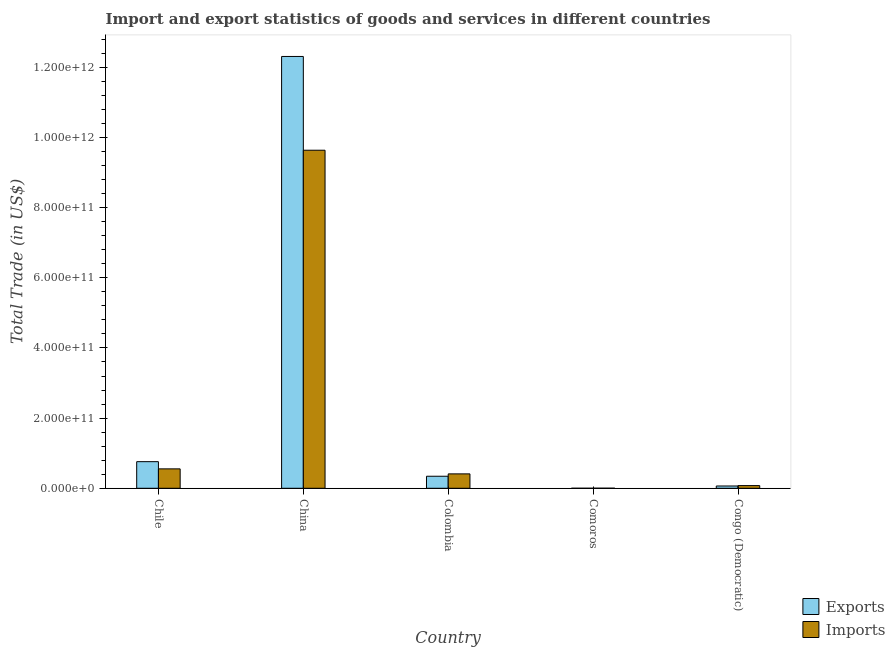Are the number of bars per tick equal to the number of legend labels?
Your response must be concise. Yes. Are the number of bars on each tick of the X-axis equal?
Make the answer very short. Yes. What is the label of the 4th group of bars from the left?
Your answer should be very brief. Comoros. What is the export of goods and services in Comoros?
Provide a short and direct response. 7.15e+07. Across all countries, what is the maximum imports of goods and services?
Provide a succinct answer. 9.63e+11. Across all countries, what is the minimum export of goods and services?
Provide a succinct answer. 7.15e+07. In which country was the imports of goods and services maximum?
Your answer should be very brief. China. In which country was the export of goods and services minimum?
Your response must be concise. Comoros. What is the total export of goods and services in the graph?
Ensure brevity in your answer.  1.35e+12. What is the difference between the export of goods and services in Comoros and that in Congo (Democratic)?
Provide a short and direct response. -6.47e+09. What is the difference between the imports of goods and services in China and the export of goods and services in Chile?
Ensure brevity in your answer.  8.88e+11. What is the average export of goods and services per country?
Provide a succinct answer. 2.69e+11. What is the difference between the export of goods and services and imports of goods and services in Colombia?
Offer a terse response. -6.74e+09. What is the ratio of the imports of goods and services in Comoros to that in Congo (Democratic)?
Your answer should be very brief. 0.03. What is the difference between the highest and the second highest imports of goods and services?
Your answer should be compact. 9.08e+11. What is the difference between the highest and the lowest imports of goods and services?
Your answer should be very brief. 9.63e+11. What does the 2nd bar from the left in Comoros represents?
Ensure brevity in your answer.  Imports. What does the 2nd bar from the right in China represents?
Your answer should be very brief. Exports. What is the difference between two consecutive major ticks on the Y-axis?
Ensure brevity in your answer.  2.00e+11. Are the values on the major ticks of Y-axis written in scientific E-notation?
Make the answer very short. Yes. Does the graph contain any zero values?
Make the answer very short. No. Does the graph contain grids?
Give a very brief answer. No. How many legend labels are there?
Your answer should be compact. 2. How are the legend labels stacked?
Provide a succinct answer. Vertical. What is the title of the graph?
Offer a very short reply. Import and export statistics of goods and services in different countries. Does "Nitrous oxide" appear as one of the legend labels in the graph?
Keep it short and to the point. No. What is the label or title of the Y-axis?
Your response must be concise. Total Trade (in US$). What is the Total Trade (in US$) in Exports in Chile?
Ensure brevity in your answer.  7.59e+1. What is the Total Trade (in US$) in Imports in Chile?
Offer a very short reply. 5.53e+1. What is the Total Trade (in US$) of Exports in China?
Keep it short and to the point. 1.23e+12. What is the Total Trade (in US$) of Imports in China?
Keep it short and to the point. 9.63e+11. What is the Total Trade (in US$) of Exports in Colombia?
Make the answer very short. 3.43e+1. What is the Total Trade (in US$) in Imports in Colombia?
Offer a very short reply. 4.10e+1. What is the Total Trade (in US$) of Exports in Comoros?
Make the answer very short. 7.15e+07. What is the Total Trade (in US$) in Imports in Comoros?
Provide a short and direct response. 1.91e+08. What is the Total Trade (in US$) of Exports in Congo (Democratic)?
Make the answer very short. 6.54e+09. What is the Total Trade (in US$) of Imports in Congo (Democratic)?
Provide a short and direct response. 7.64e+09. Across all countries, what is the maximum Total Trade (in US$) in Exports?
Your answer should be very brief. 1.23e+12. Across all countries, what is the maximum Total Trade (in US$) in Imports?
Offer a very short reply. 9.63e+11. Across all countries, what is the minimum Total Trade (in US$) of Exports?
Make the answer very short. 7.15e+07. Across all countries, what is the minimum Total Trade (in US$) of Imports?
Provide a short and direct response. 1.91e+08. What is the total Total Trade (in US$) of Exports in the graph?
Provide a succinct answer. 1.35e+12. What is the total Total Trade (in US$) of Imports in the graph?
Provide a succinct answer. 1.07e+12. What is the difference between the Total Trade (in US$) in Exports in Chile and that in China?
Your answer should be very brief. -1.15e+12. What is the difference between the Total Trade (in US$) of Imports in Chile and that in China?
Make the answer very short. -9.08e+11. What is the difference between the Total Trade (in US$) in Exports in Chile and that in Colombia?
Ensure brevity in your answer.  4.16e+1. What is the difference between the Total Trade (in US$) in Imports in Chile and that in Colombia?
Offer a very short reply. 1.43e+1. What is the difference between the Total Trade (in US$) in Exports in Chile and that in Comoros?
Your response must be concise. 7.58e+1. What is the difference between the Total Trade (in US$) of Imports in Chile and that in Comoros?
Offer a terse response. 5.51e+1. What is the difference between the Total Trade (in US$) of Exports in Chile and that in Congo (Democratic)?
Provide a succinct answer. 6.93e+1. What is the difference between the Total Trade (in US$) in Imports in Chile and that in Congo (Democratic)?
Your answer should be very brief. 4.77e+1. What is the difference between the Total Trade (in US$) in Exports in China and that in Colombia?
Your answer should be compact. 1.20e+12. What is the difference between the Total Trade (in US$) in Imports in China and that in Colombia?
Give a very brief answer. 9.22e+11. What is the difference between the Total Trade (in US$) in Exports in China and that in Comoros?
Your answer should be very brief. 1.23e+12. What is the difference between the Total Trade (in US$) of Imports in China and that in Comoros?
Your answer should be very brief. 9.63e+11. What is the difference between the Total Trade (in US$) in Exports in China and that in Congo (Democratic)?
Offer a terse response. 1.22e+12. What is the difference between the Total Trade (in US$) of Imports in China and that in Congo (Democratic)?
Provide a short and direct response. 9.56e+11. What is the difference between the Total Trade (in US$) of Exports in Colombia and that in Comoros?
Offer a very short reply. 3.42e+1. What is the difference between the Total Trade (in US$) of Imports in Colombia and that in Comoros?
Offer a very short reply. 4.09e+1. What is the difference between the Total Trade (in US$) of Exports in Colombia and that in Congo (Democratic)?
Give a very brief answer. 2.78e+1. What is the difference between the Total Trade (in US$) of Imports in Colombia and that in Congo (Democratic)?
Give a very brief answer. 3.34e+1. What is the difference between the Total Trade (in US$) of Exports in Comoros and that in Congo (Democratic)?
Give a very brief answer. -6.47e+09. What is the difference between the Total Trade (in US$) in Imports in Comoros and that in Congo (Democratic)?
Provide a succinct answer. -7.45e+09. What is the difference between the Total Trade (in US$) in Exports in Chile and the Total Trade (in US$) in Imports in China?
Offer a very short reply. -8.88e+11. What is the difference between the Total Trade (in US$) in Exports in Chile and the Total Trade (in US$) in Imports in Colombia?
Your response must be concise. 3.48e+1. What is the difference between the Total Trade (in US$) of Exports in Chile and the Total Trade (in US$) of Imports in Comoros?
Offer a very short reply. 7.57e+1. What is the difference between the Total Trade (in US$) of Exports in Chile and the Total Trade (in US$) of Imports in Congo (Democratic)?
Offer a terse response. 6.82e+1. What is the difference between the Total Trade (in US$) in Exports in China and the Total Trade (in US$) in Imports in Colombia?
Your answer should be compact. 1.19e+12. What is the difference between the Total Trade (in US$) in Exports in China and the Total Trade (in US$) in Imports in Comoros?
Your response must be concise. 1.23e+12. What is the difference between the Total Trade (in US$) of Exports in China and the Total Trade (in US$) of Imports in Congo (Democratic)?
Provide a short and direct response. 1.22e+12. What is the difference between the Total Trade (in US$) of Exports in Colombia and the Total Trade (in US$) of Imports in Comoros?
Offer a terse response. 3.41e+1. What is the difference between the Total Trade (in US$) of Exports in Colombia and the Total Trade (in US$) of Imports in Congo (Democratic)?
Provide a short and direct response. 2.67e+1. What is the difference between the Total Trade (in US$) of Exports in Comoros and the Total Trade (in US$) of Imports in Congo (Democratic)?
Provide a succinct answer. -7.57e+09. What is the average Total Trade (in US$) in Exports per country?
Make the answer very short. 2.69e+11. What is the average Total Trade (in US$) of Imports per country?
Keep it short and to the point. 2.14e+11. What is the difference between the Total Trade (in US$) of Exports and Total Trade (in US$) of Imports in Chile?
Your response must be concise. 2.05e+1. What is the difference between the Total Trade (in US$) in Exports and Total Trade (in US$) in Imports in China?
Your answer should be very brief. 2.67e+11. What is the difference between the Total Trade (in US$) of Exports and Total Trade (in US$) of Imports in Colombia?
Provide a short and direct response. -6.74e+09. What is the difference between the Total Trade (in US$) in Exports and Total Trade (in US$) in Imports in Comoros?
Ensure brevity in your answer.  -1.20e+08. What is the difference between the Total Trade (in US$) in Exports and Total Trade (in US$) in Imports in Congo (Democratic)?
Your response must be concise. -1.10e+09. What is the ratio of the Total Trade (in US$) of Exports in Chile to that in China?
Ensure brevity in your answer.  0.06. What is the ratio of the Total Trade (in US$) in Imports in Chile to that in China?
Provide a short and direct response. 0.06. What is the ratio of the Total Trade (in US$) of Exports in Chile to that in Colombia?
Keep it short and to the point. 2.21. What is the ratio of the Total Trade (in US$) of Imports in Chile to that in Colombia?
Provide a succinct answer. 1.35. What is the ratio of the Total Trade (in US$) of Exports in Chile to that in Comoros?
Provide a succinct answer. 1061.14. What is the ratio of the Total Trade (in US$) of Imports in Chile to that in Comoros?
Provide a short and direct response. 289.09. What is the ratio of the Total Trade (in US$) of Exports in Chile to that in Congo (Democratic)?
Provide a short and direct response. 11.6. What is the ratio of the Total Trade (in US$) in Imports in Chile to that in Congo (Democratic)?
Your answer should be compact. 7.24. What is the ratio of the Total Trade (in US$) in Exports in China to that in Colombia?
Offer a terse response. 35.88. What is the ratio of the Total Trade (in US$) in Imports in China to that in Colombia?
Provide a short and direct response. 23.47. What is the ratio of the Total Trade (in US$) in Exports in China to that in Comoros?
Offer a very short reply. 1.72e+04. What is the ratio of the Total Trade (in US$) of Imports in China to that in Comoros?
Offer a very short reply. 5035.17. What is the ratio of the Total Trade (in US$) in Exports in China to that in Congo (Democratic)?
Keep it short and to the point. 188.2. What is the ratio of the Total Trade (in US$) of Imports in China to that in Congo (Democratic)?
Provide a short and direct response. 126.1. What is the ratio of the Total Trade (in US$) of Exports in Colombia to that in Comoros?
Offer a very short reply. 479.89. What is the ratio of the Total Trade (in US$) in Imports in Colombia to that in Comoros?
Your answer should be compact. 214.52. What is the ratio of the Total Trade (in US$) of Exports in Colombia to that in Congo (Democratic)?
Give a very brief answer. 5.25. What is the ratio of the Total Trade (in US$) of Imports in Colombia to that in Congo (Democratic)?
Ensure brevity in your answer.  5.37. What is the ratio of the Total Trade (in US$) of Exports in Comoros to that in Congo (Democratic)?
Your answer should be very brief. 0.01. What is the ratio of the Total Trade (in US$) of Imports in Comoros to that in Congo (Democratic)?
Keep it short and to the point. 0.03. What is the difference between the highest and the second highest Total Trade (in US$) of Exports?
Your answer should be compact. 1.15e+12. What is the difference between the highest and the second highest Total Trade (in US$) of Imports?
Provide a short and direct response. 9.08e+11. What is the difference between the highest and the lowest Total Trade (in US$) of Exports?
Provide a short and direct response. 1.23e+12. What is the difference between the highest and the lowest Total Trade (in US$) in Imports?
Offer a terse response. 9.63e+11. 